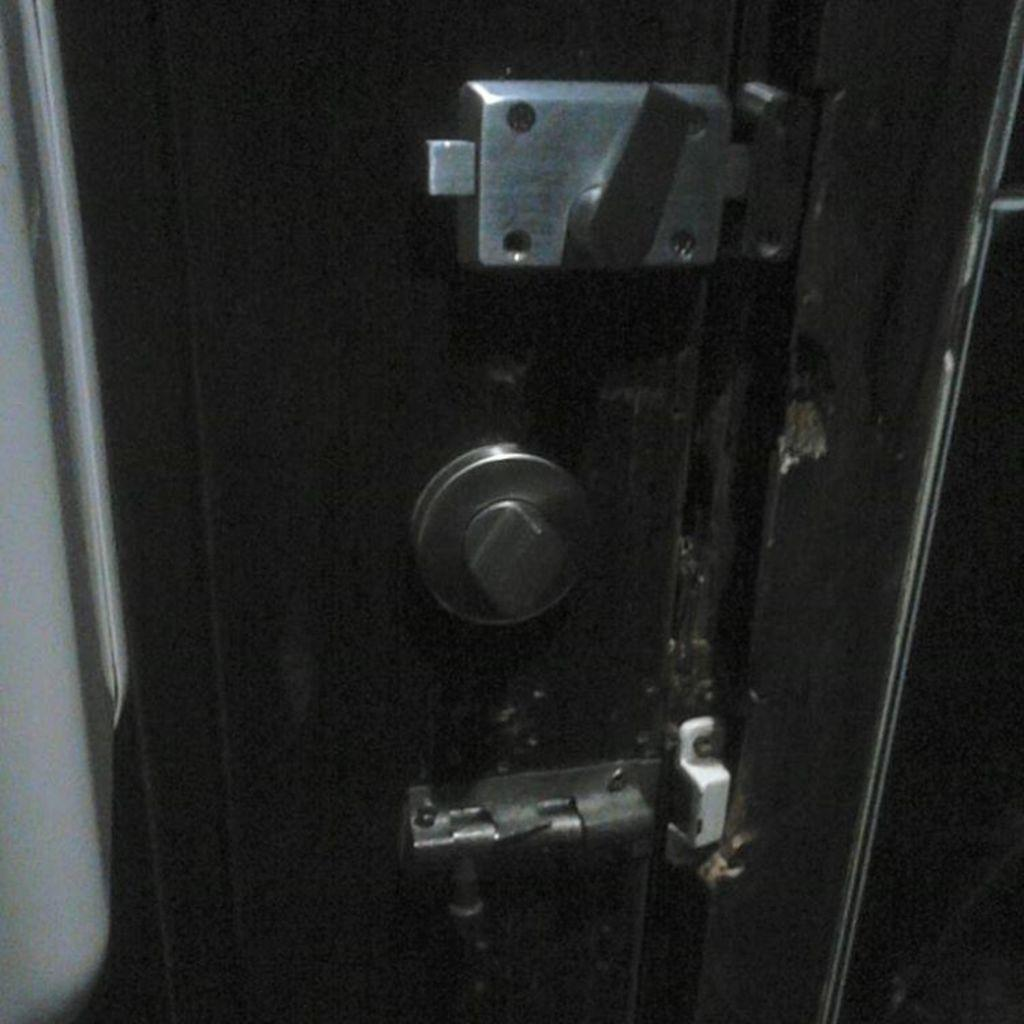What can be found in the image that allows access to a room or space? There is a door in the image that allows access to a room or space. How many locks are present on the door in the image? The door has three different types of locks. What does the brother say when he falls in the image? There is no brother or falling depicted in the image; it only features a door with three locks. 